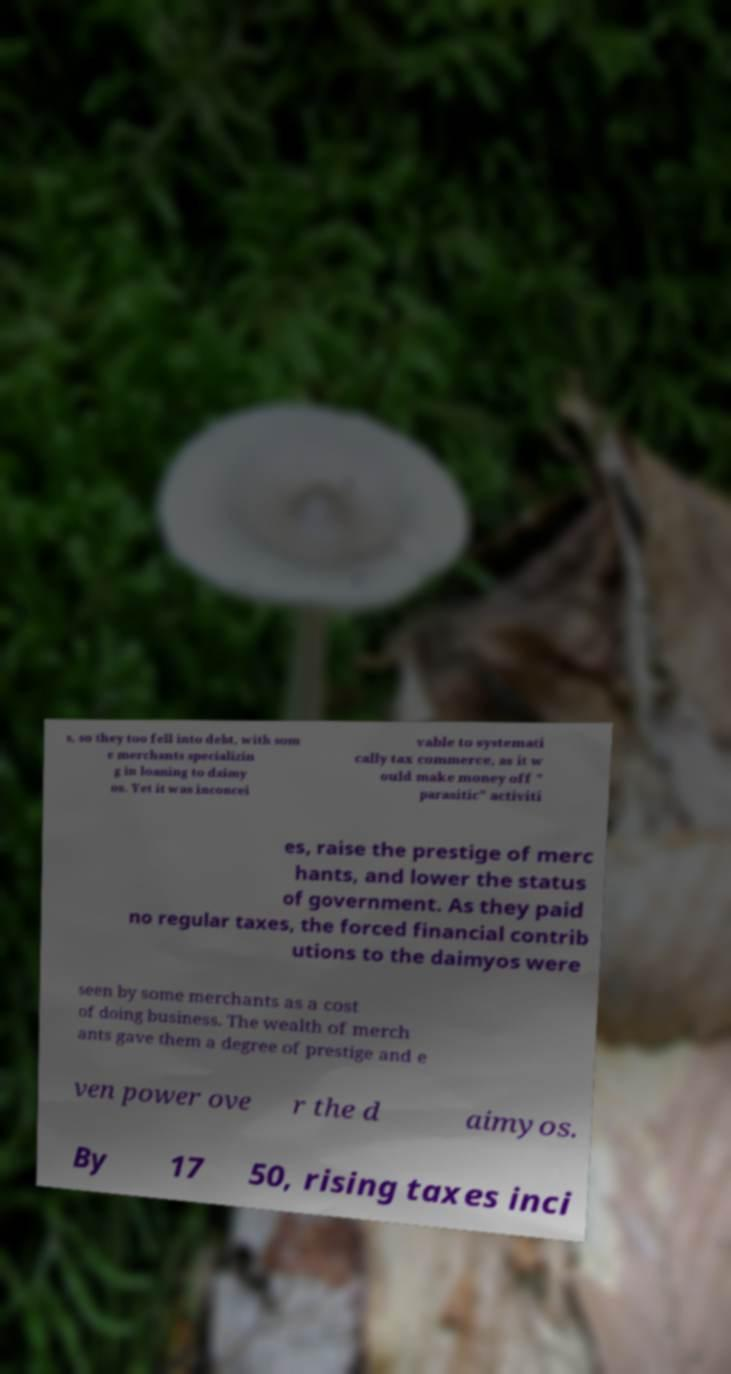I need the written content from this picture converted into text. Can you do that? s, so they too fell into debt, with som e merchants specializin g in loaning to daimy os. Yet it was inconcei vable to systemati cally tax commerce, as it w ould make money off " parasitic" activiti es, raise the prestige of merc hants, and lower the status of government. As they paid no regular taxes, the forced financial contrib utions to the daimyos were seen by some merchants as a cost of doing business. The wealth of merch ants gave them a degree of prestige and e ven power ove r the d aimyos. By 17 50, rising taxes inci 